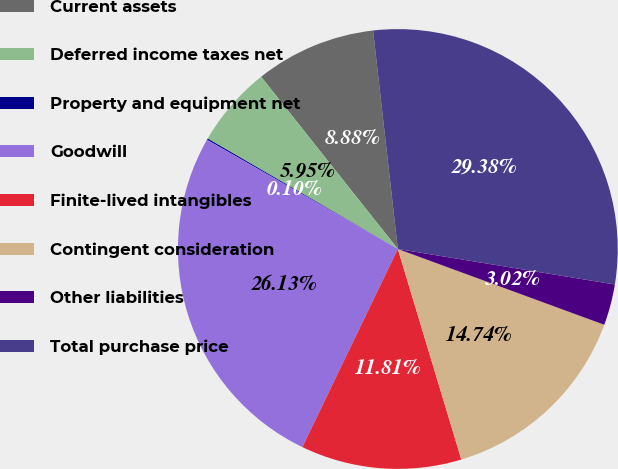<chart> <loc_0><loc_0><loc_500><loc_500><pie_chart><fcel>Current assets<fcel>Deferred income taxes net<fcel>Property and equipment net<fcel>Goodwill<fcel>Finite-lived intangibles<fcel>Contingent consideration<fcel>Other liabilities<fcel>Total purchase price<nl><fcel>8.88%<fcel>5.95%<fcel>0.1%<fcel>26.13%<fcel>11.81%<fcel>14.74%<fcel>3.02%<fcel>29.38%<nl></chart> 